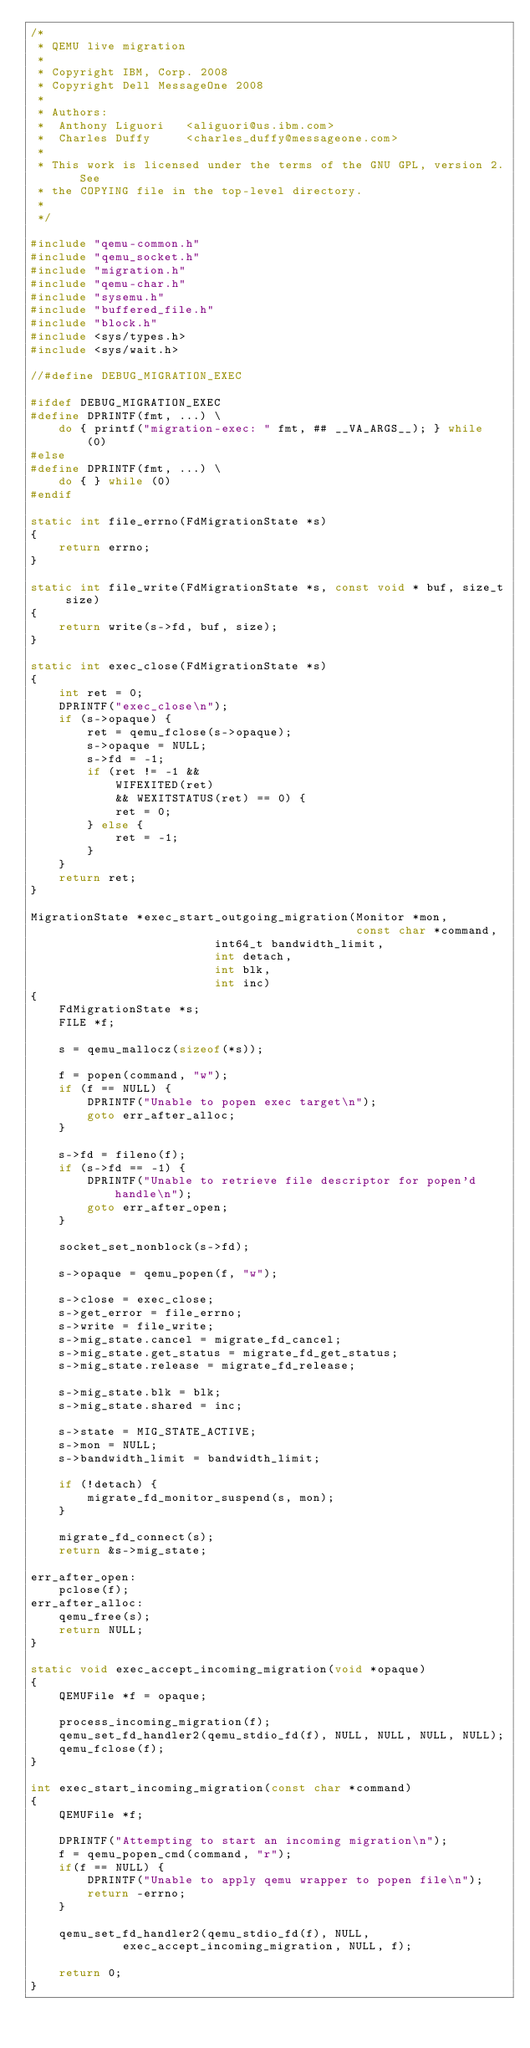<code> <loc_0><loc_0><loc_500><loc_500><_C_>/*
 * QEMU live migration
 *
 * Copyright IBM, Corp. 2008
 * Copyright Dell MessageOne 2008
 *
 * Authors:
 *  Anthony Liguori   <aliguori@us.ibm.com>
 *  Charles Duffy     <charles_duffy@messageone.com>
 *
 * This work is licensed under the terms of the GNU GPL, version 2.  See
 * the COPYING file in the top-level directory.
 *
 */

#include "qemu-common.h"
#include "qemu_socket.h"
#include "migration.h"
#include "qemu-char.h"
#include "sysemu.h"
#include "buffered_file.h"
#include "block.h"
#include <sys/types.h>
#include <sys/wait.h>

//#define DEBUG_MIGRATION_EXEC

#ifdef DEBUG_MIGRATION_EXEC
#define DPRINTF(fmt, ...) \
    do { printf("migration-exec: " fmt, ## __VA_ARGS__); } while (0)
#else
#define DPRINTF(fmt, ...) \
    do { } while (0)
#endif

static int file_errno(FdMigrationState *s)
{
    return errno;
}

static int file_write(FdMigrationState *s, const void * buf, size_t size)
{
    return write(s->fd, buf, size);
}

static int exec_close(FdMigrationState *s)
{
    int ret = 0;
    DPRINTF("exec_close\n");
    if (s->opaque) {
        ret = qemu_fclose(s->opaque);
        s->opaque = NULL;
        s->fd = -1;
        if (ret != -1 &&
            WIFEXITED(ret)
            && WEXITSTATUS(ret) == 0) {
            ret = 0;
        } else {
            ret = -1;
        }
    }
    return ret;
}

MigrationState *exec_start_outgoing_migration(Monitor *mon,
                                              const char *command,
					      int64_t bandwidth_limit,
					      int detach,
					      int blk,
					      int inc)
{
    FdMigrationState *s;
    FILE *f;

    s = qemu_mallocz(sizeof(*s));

    f = popen(command, "w");
    if (f == NULL) {
        DPRINTF("Unable to popen exec target\n");
        goto err_after_alloc;
    }

    s->fd = fileno(f);
    if (s->fd == -1) {
        DPRINTF("Unable to retrieve file descriptor for popen'd handle\n");
        goto err_after_open;
    }

    socket_set_nonblock(s->fd);

    s->opaque = qemu_popen(f, "w");

    s->close = exec_close;
    s->get_error = file_errno;
    s->write = file_write;
    s->mig_state.cancel = migrate_fd_cancel;
    s->mig_state.get_status = migrate_fd_get_status;
    s->mig_state.release = migrate_fd_release;

    s->mig_state.blk = blk;
    s->mig_state.shared = inc;

    s->state = MIG_STATE_ACTIVE;
    s->mon = NULL;
    s->bandwidth_limit = bandwidth_limit;

    if (!detach) {
        migrate_fd_monitor_suspend(s, mon);
    }

    migrate_fd_connect(s);
    return &s->mig_state;

err_after_open:
    pclose(f);
err_after_alloc:
    qemu_free(s);
    return NULL;
}

static void exec_accept_incoming_migration(void *opaque)
{
    QEMUFile *f = opaque;

    process_incoming_migration(f);
    qemu_set_fd_handler2(qemu_stdio_fd(f), NULL, NULL, NULL, NULL);
    qemu_fclose(f);
}

int exec_start_incoming_migration(const char *command)
{
    QEMUFile *f;

    DPRINTF("Attempting to start an incoming migration\n");
    f = qemu_popen_cmd(command, "r");
    if(f == NULL) {
        DPRINTF("Unable to apply qemu wrapper to popen file\n");
        return -errno;
    }

    qemu_set_fd_handler2(qemu_stdio_fd(f), NULL,
			 exec_accept_incoming_migration, NULL, f);

    return 0;
}
</code> 